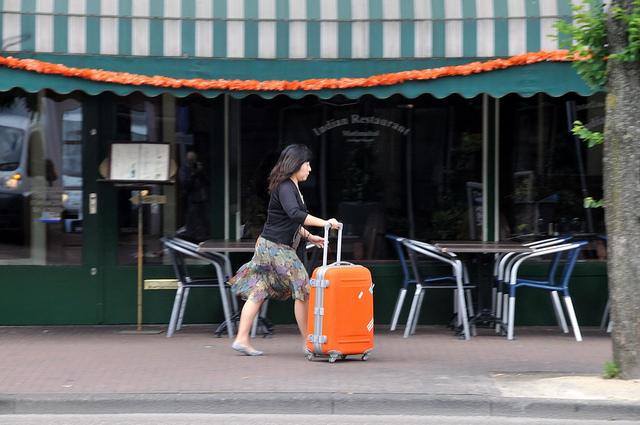Please transcribe the text information in this image. Restaurant 